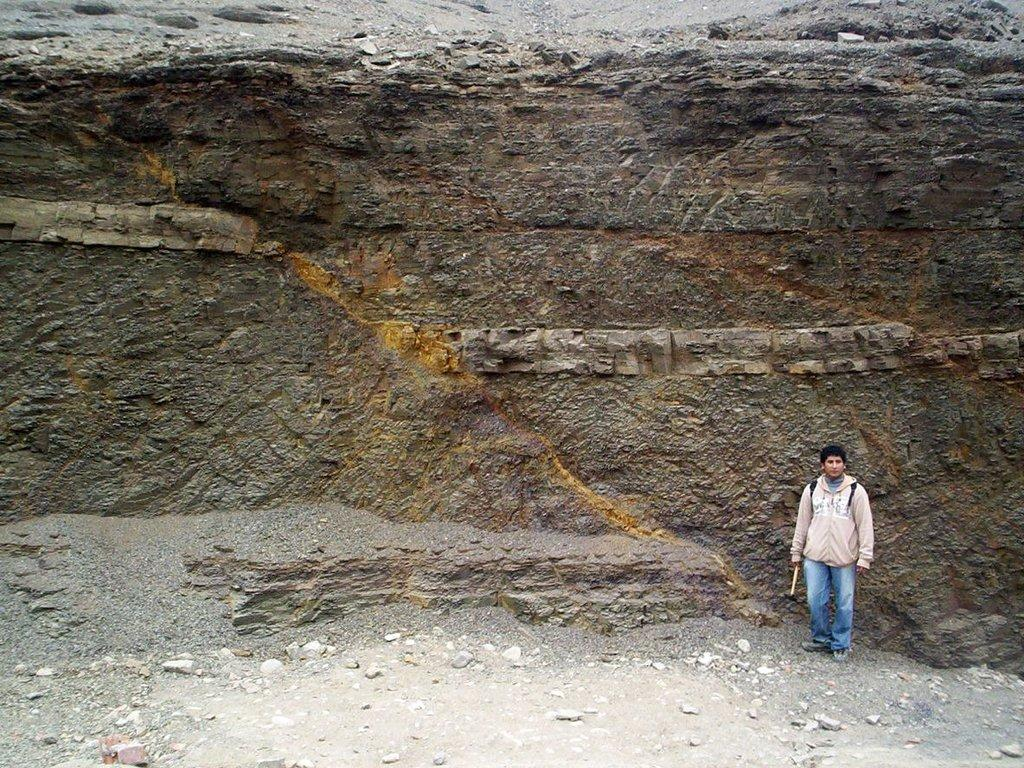What is the main subject of the image? There is a man standing in the image. Where is the man standing? The man is standing on the floor. What can be seen in the background of the image? There is a big wall in the background of the image. What type of material is present on the floor? There are stones and sand on the floor in the image. How many mice are hiding behind the stones on the floor in the image? There are no mice present in the image; it only shows a man standing on the floor with stones and sand. What type of potato can be seen growing in the sand in the image? There is no potato present in the image; it only shows a man standing on the floor with stones and sand. 